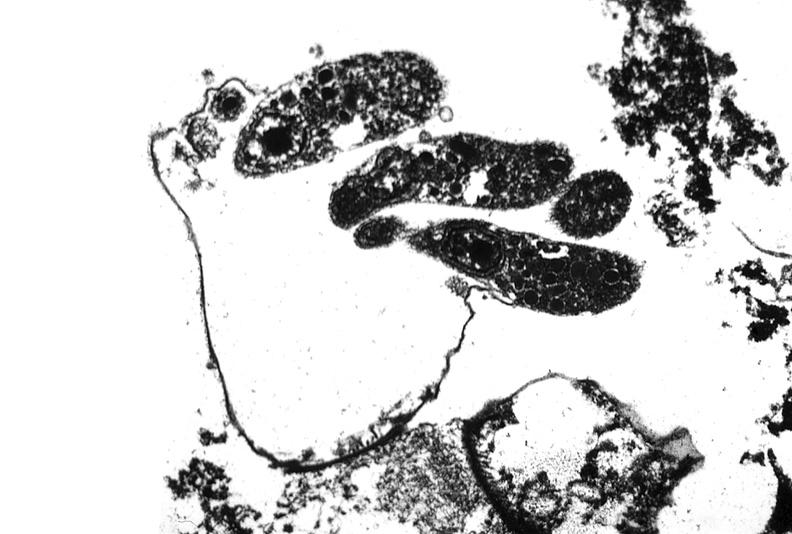does this image show colon biopsy, cryptosporidia?
Answer the question using a single word or phrase. Yes 